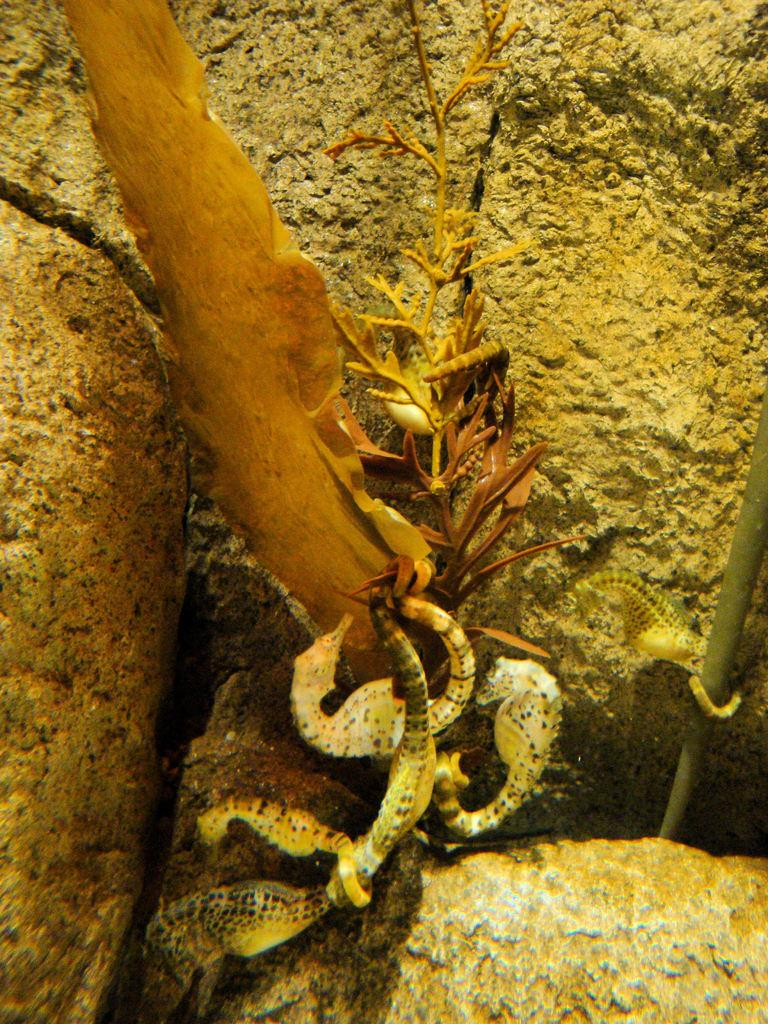What type of animals are present in the image? There are reptiles in the image. What can be seen in the background of the image? There are rocks in the background of the image. Is there any quicksand present in the image? There is no quicksand present in the image. What type of print can be seen on the reptiles in the image? The reptiles in the image do not have any visible prints. 